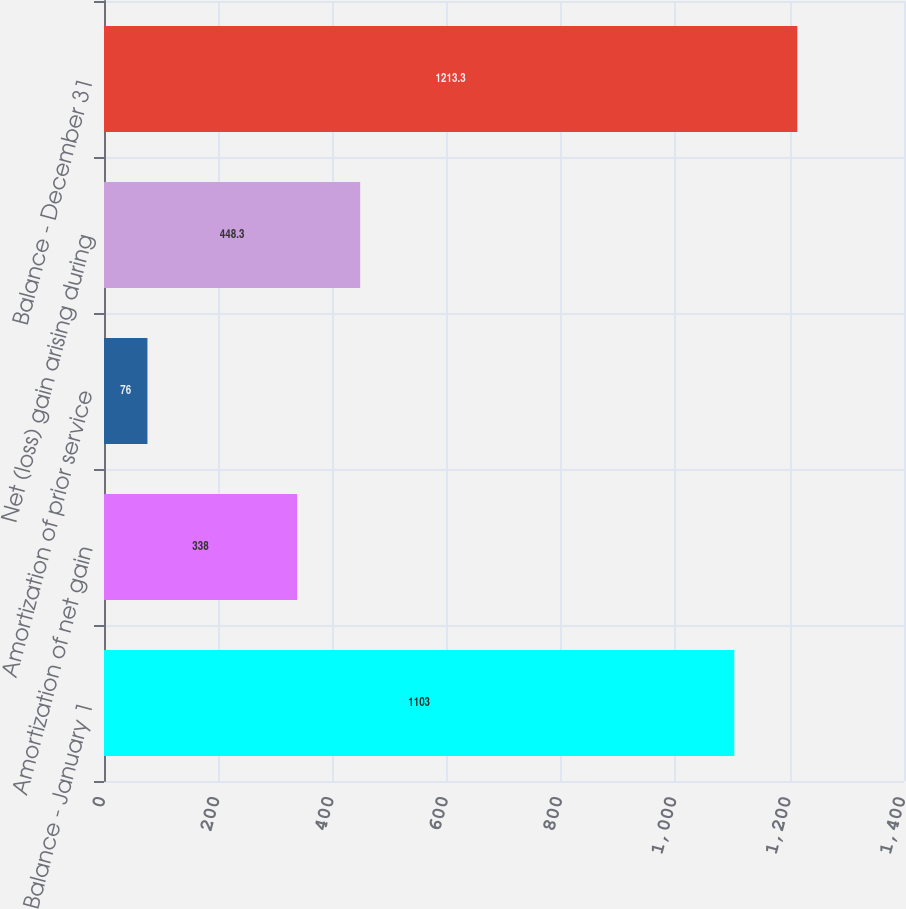<chart> <loc_0><loc_0><loc_500><loc_500><bar_chart><fcel>Balance - January 1<fcel>Amortization of net gain<fcel>Amortization of prior service<fcel>Net (loss) gain arising during<fcel>Balance - December 31<nl><fcel>1103<fcel>338<fcel>76<fcel>448.3<fcel>1213.3<nl></chart> 